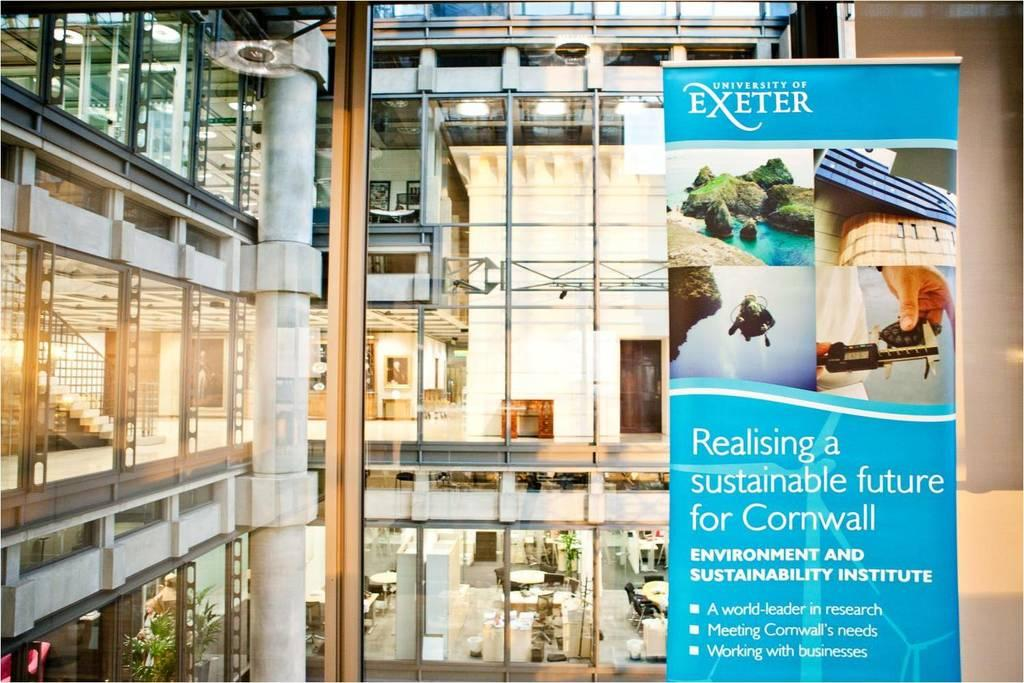<image>
Present a compact description of the photo's key features. a sign that has the word Exeter on it 